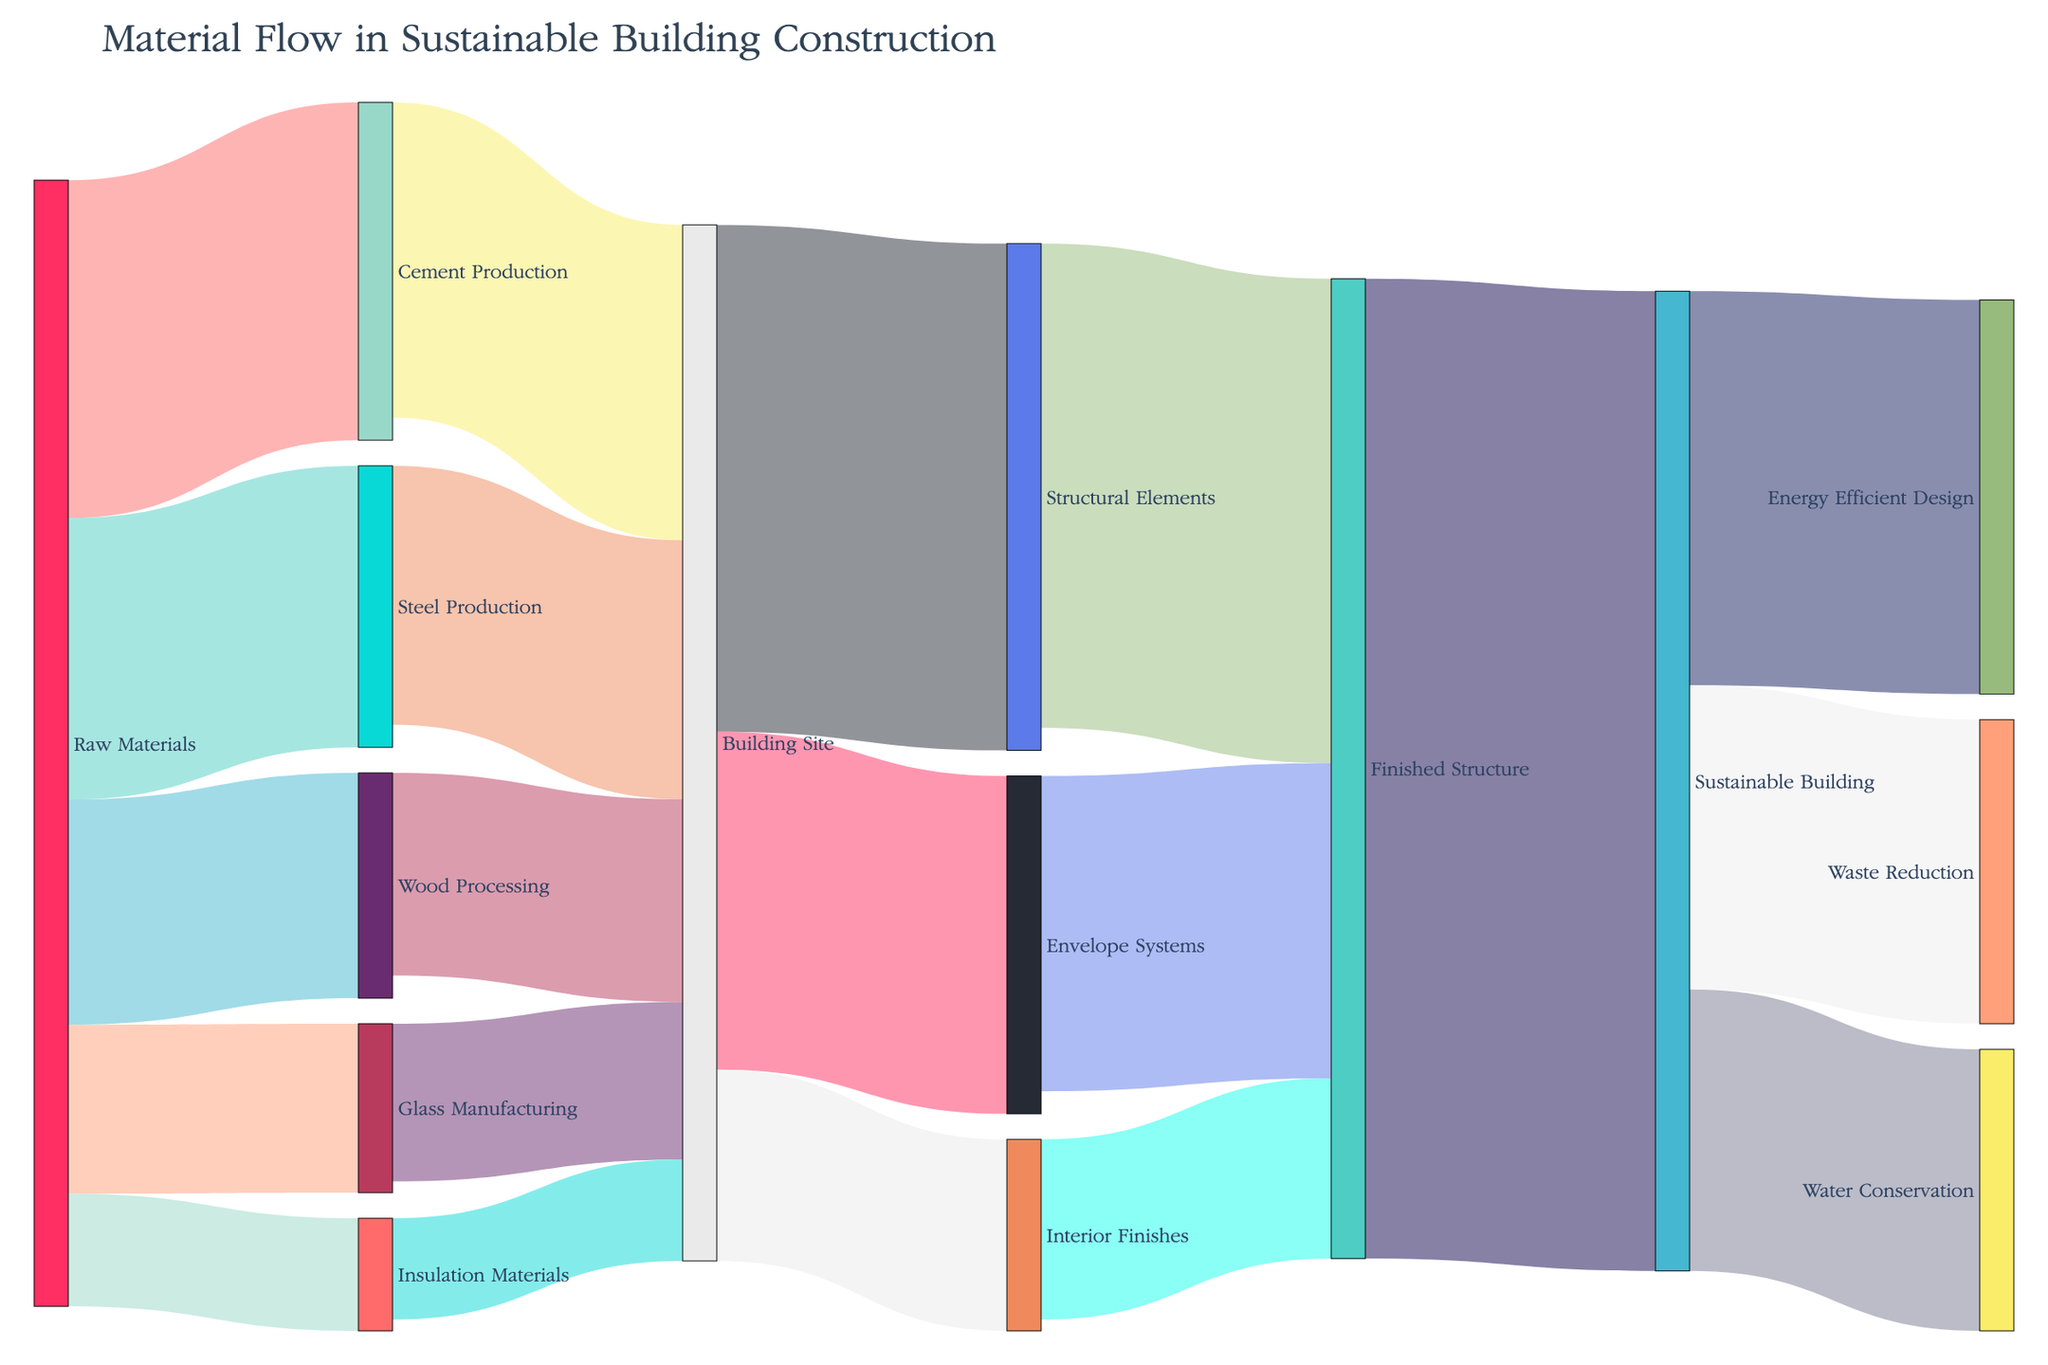how many nodes are involved in the material flow? To count the number of nodes involved in the material flow, count unique entities labeled either as sources or targets. The sources include "Raw Materials," "Cement Production," "Steel Production," "Wood Processing," "Glass Manufacturing," "Insulation Materials," "Building Site," "Structural Elements," "Envelope Systems," "Interior Finishes," "Finished Structure," and "Sustainable Building."
Answer: 12 Which production process receives the highest flow of raw materials? Referring to the flow values from "Raw Materials," the highest value is 30, which is directed toward "Cement Production."
Answer: Cement Production What is the total material flow into the building site? Sum the values flowing into the "Building Site" from all sources: Cement Production (28) + Steel Production (23) + Wood Processing (18) + Glass Manufacturing (14) + Insulation Materials (9). The total is 92.
Answer: 92 Comparing the finished structure to the sustainable building, which has greater total inflow? The flow into the "Finished Structure" is 43 (Structural Elements) + 28 (Envelope Systems) + 16 (Interior Finishes) which totals to 87. The flow into "Sustainable Building" is 87 (from Finished Structure). Both have the same inflow value (87).
Answer: Both have the same value How much material flow is directed towards water conservation from the sustainable building? The flow value directed from "Sustainable Building" to "Water Conservation" is 25.
Answer: 25 If the link from raw materials to steel production is removed, what will be the new total inflow into the building site? The current inflow from "Steel Production" to "Building Site" is 23. Removing it, the new inflow is 92 - 23 = 69.
Answer: 69 Which downstream category receives more materials from the building site: Structural Elements or Envelope Systems? Summing the flow values from "Building Site," Structural Elements receive 45, whereas Envelope Systems receive 30. Structural Elements receive more.
Answer: Structural Elements How many distinct material categories directly contribute to the finished structure? These categories are "Structural Elements," "Envelope Systems," and "Interior Finishes." Count these categories.
Answer: 3 From the provided data, calculate the non-recycled materials accounted for in the sustainable building. Non-recyclable can be inferred from the outflow of "Sustainable Building:" 35 (Energy Efficient Design) + 25 (Water Conservation) + 27 (Waste Reduction) = 87.
Answer: 87 How much more material flows into the structural elements than the interior finishes? The material flow into "Structural Elements" is 45, and into "Interior Finishes" is 17. The difference is 45 - 17 = 28.
Answer: 28 